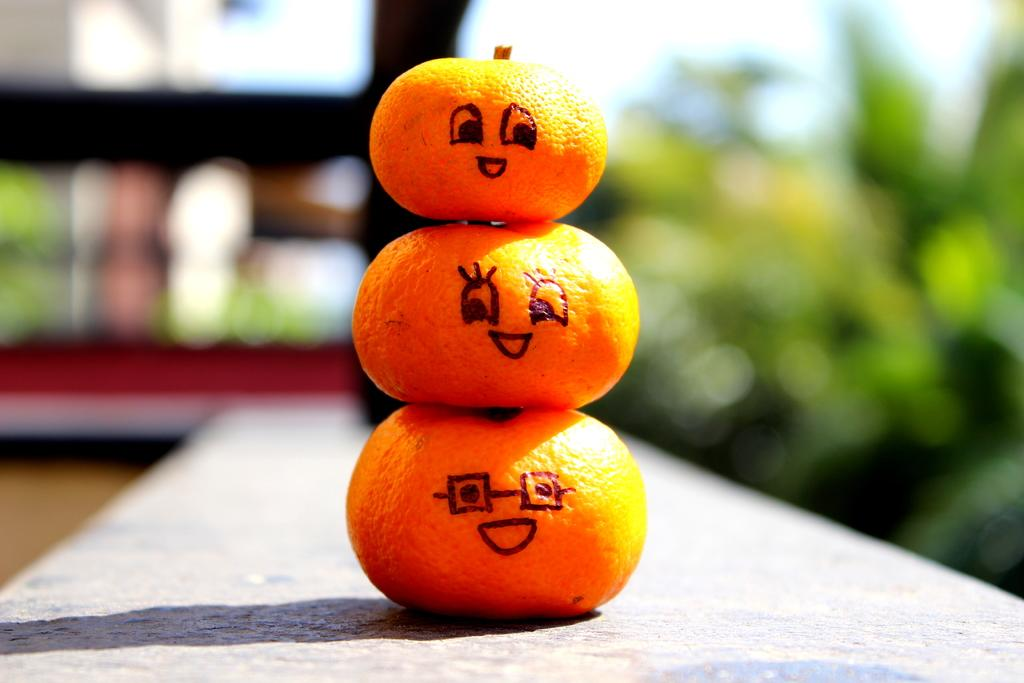How many oranges are visible in the image? There are three oranges in the image. How are the oranges arranged in the image? The oranges are placed one on top of the other. What additional features are present on the oranges? Eyes and a mouth are drawn on the oranges using a marker. What type of sock is being used to hold the oranges together in the image? There is no sock present in the image; the oranges are simply placed one on top of the other. 